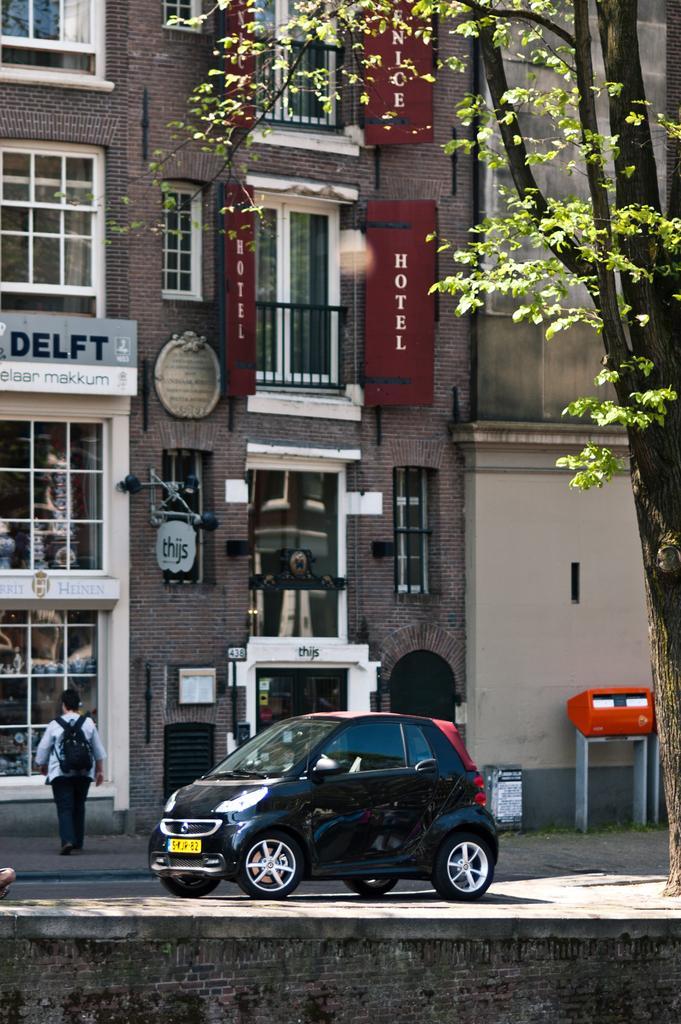In one or two sentences, can you explain what this image depicts? In this image, we can see a person in front of the building. There is a car at the bottom of the image. There is a tree on the right side of the image. 